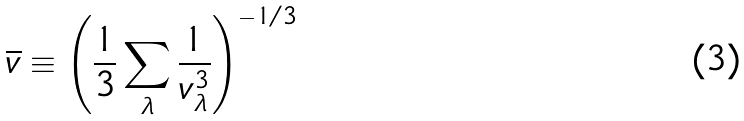Convert formula to latex. <formula><loc_0><loc_0><loc_500><loc_500>\overline { v } \equiv \left ( \frac { 1 } { 3 } \sum _ { \lambda } \frac { 1 } { v _ { \lambda } ^ { 3 } } \right ) ^ { - 1 / 3 }</formula> 